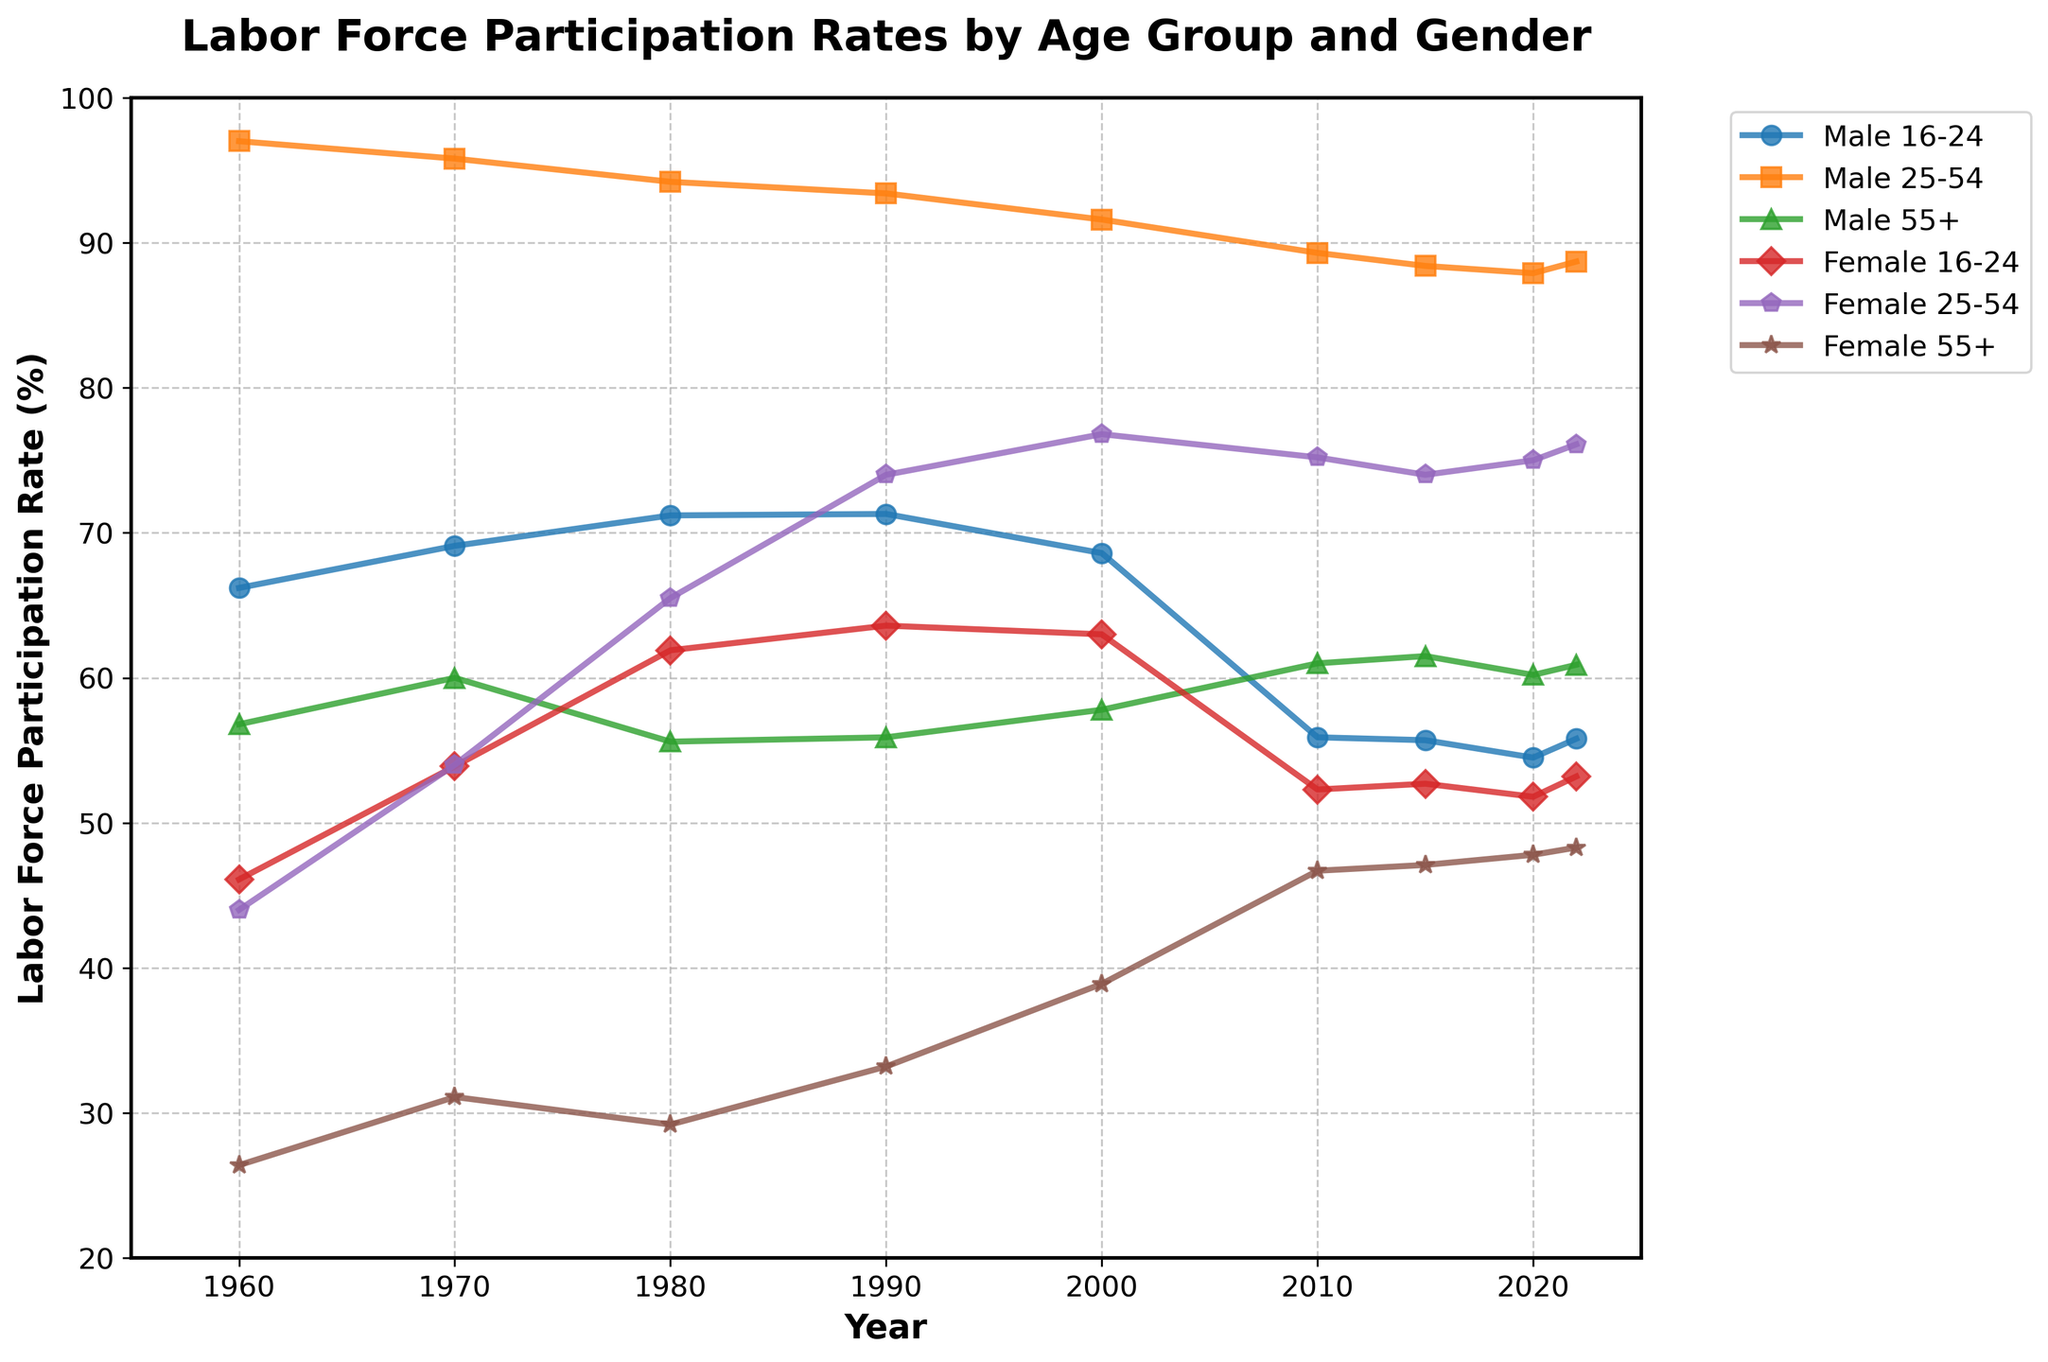What was the labor force participation rate for males aged 25-54 in 2020? To find the answer, look at the line labeled "Male 25-54" and locate the point for the year 2020 on the x-axis. The corresponding y-value gives the participation rate.
Answer: 87.9 Which gender and age group saw the highest increase in labor force participation rate between 1960 and 2022? Calculate the change in participation rate for each gender and age group from 1960 to 2022. The largest increase corresponds to the group with the highest difference in y-values between these years.
Answer: Female 25-54 What is the difference in labor force participation rates between males aged 16-24 and females aged 16-24 in 2022? Find the participation rates for both groups in 2022 and calculate the difference by subtracting the female rate from the male rate.
Answer: 2.6 What trend can be observed for labor force participation rates of males aged 55+ from 1960 to 2022? Observe the line for "Male 55+" from 1960 to 2022. A trend can be determined by the general direction (increasing, decreasing, or stable) of the line over time.
Answer: Increasing Which age group of females had the highest labor force participation rate in 2010? Compare the points for the year 2010 across the three female age groups (16-24, 25-54, 55+). The highest y-value indicates the group with the highest participation rate.
Answer: Female 25-54 By how much did the labor force participation rate for females aged 16-24 decrease between 2000 and 2010? Find the participation rates for this group in 2000 and 2010, and then calculate the difference by subtracting the latter from the former.
Answer: 10.7 Which group showed the least change in labor force participation rates between 2010 and 2022? Calculate the change for each group by finding the difference in participation rates between 2010 and 2022. The smallest absolute difference indicates the group with the least change.
Answer: Female 25-54 What is the average labor force participation rate for males aged 55+ across all the years provided? Sum the participation rates for males aged 55+ across all years and divide by the number of years.
Answer: 58.8 In which year did females aged 25-54 surpass a 70% labor force participation rate? Look at the "Female 25-54" line and find the first year where the y-value exceeds 70%.
Answer: 1990 How does the labor force participation rate for males aged 16-24 in 2022 compare with that in 1960? Identify the rates for males aged 16-24 in 1960 and 2022, then compare the two values to determine whether the rate increased or decreased.
Answer: Decreased 